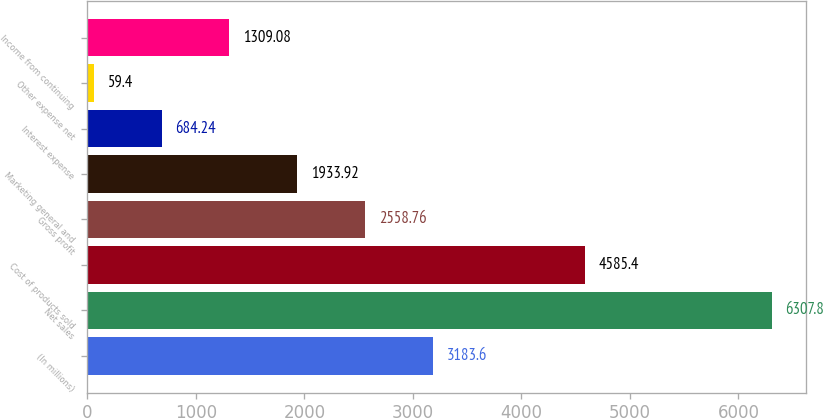<chart> <loc_0><loc_0><loc_500><loc_500><bar_chart><fcel>(In millions)<fcel>Net sales<fcel>Cost of products sold<fcel>Gross profit<fcel>Marketing general and<fcel>Interest expense<fcel>Other expense net<fcel>Income from continuing<nl><fcel>3183.6<fcel>6307.8<fcel>4585.4<fcel>2558.76<fcel>1933.92<fcel>684.24<fcel>59.4<fcel>1309.08<nl></chart> 